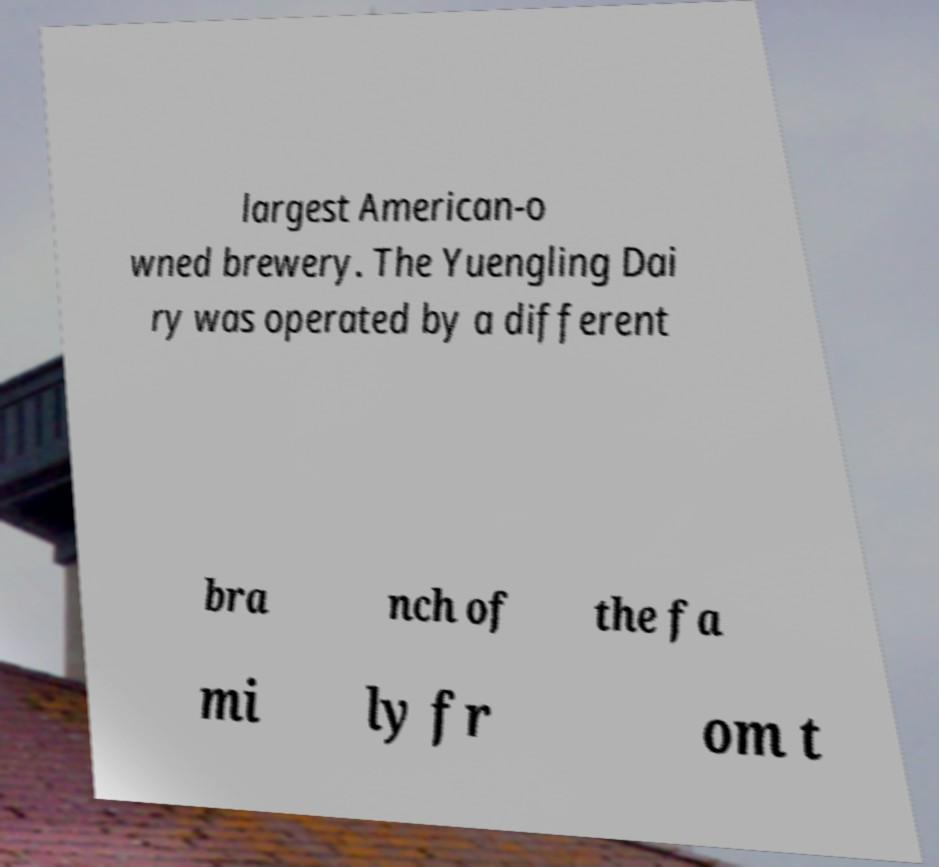Can you read and provide the text displayed in the image?This photo seems to have some interesting text. Can you extract and type it out for me? largest American-o wned brewery. The Yuengling Dai ry was operated by a different bra nch of the fa mi ly fr om t 